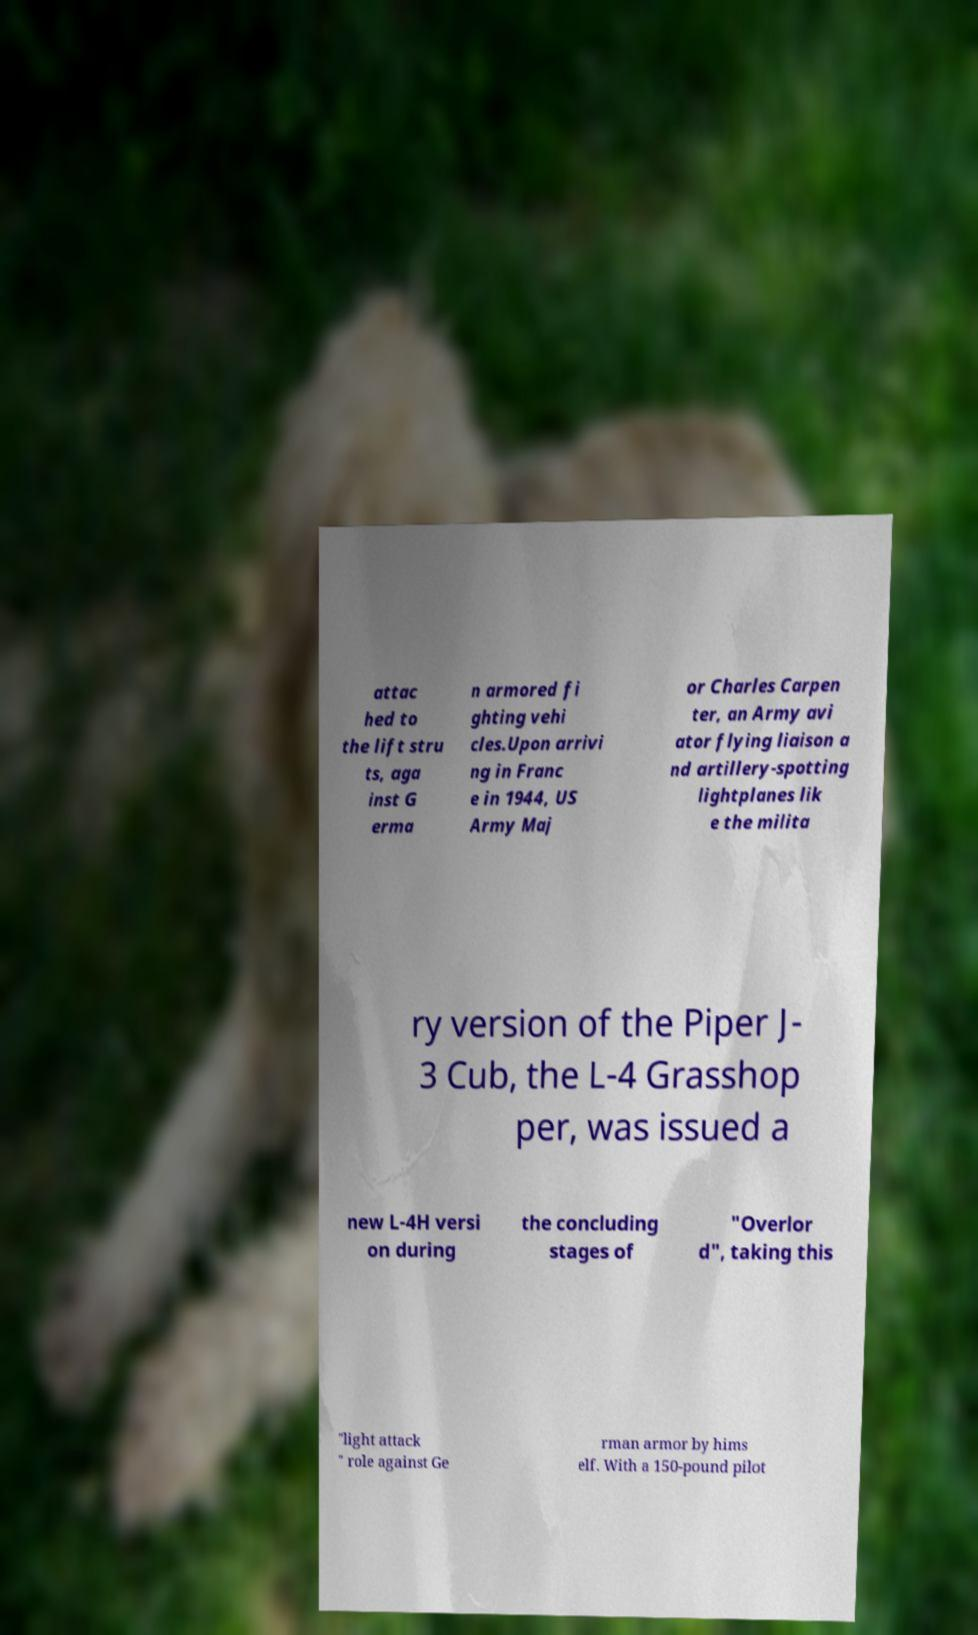Can you read and provide the text displayed in the image?This photo seems to have some interesting text. Can you extract and type it out for me? attac hed to the lift stru ts, aga inst G erma n armored fi ghting vehi cles.Upon arrivi ng in Franc e in 1944, US Army Maj or Charles Carpen ter, an Army avi ator flying liaison a nd artillery-spotting lightplanes lik e the milita ry version of the Piper J- 3 Cub, the L-4 Grasshop per, was issued a new L-4H versi on during the concluding stages of "Overlor d", taking this "light attack " role against Ge rman armor by hims elf. With a 150-pound pilot 